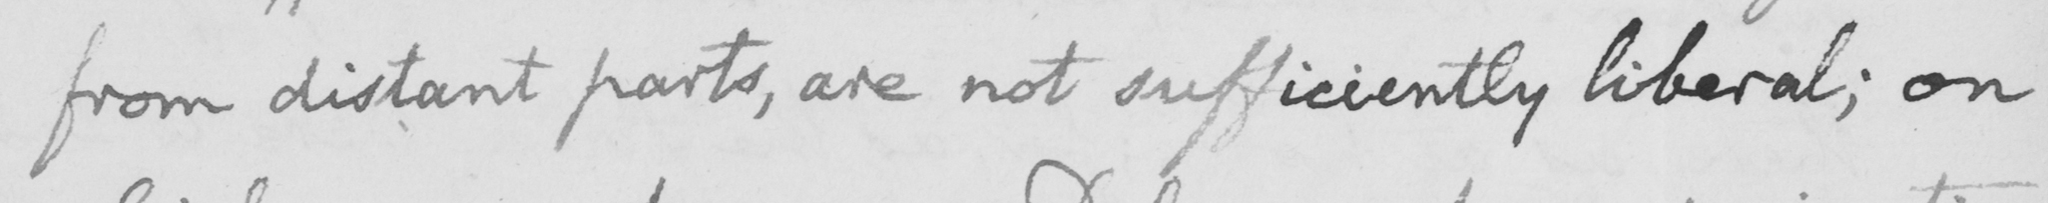Can you read and transcribe this handwriting? from distant parts, are not sufficiently liberal; on 